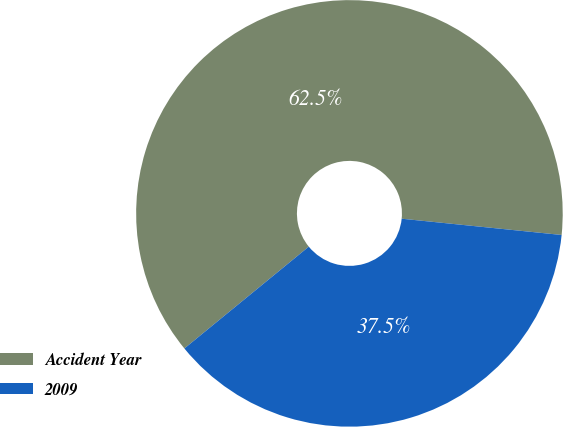Convert chart to OTSL. <chart><loc_0><loc_0><loc_500><loc_500><pie_chart><fcel>Accident Year<fcel>2009<nl><fcel>62.53%<fcel>37.47%<nl></chart> 